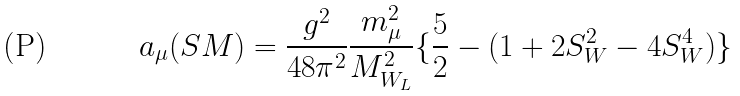Convert formula to latex. <formula><loc_0><loc_0><loc_500><loc_500>a _ { \mu } ( S M ) = \frac { g ^ { 2 } } { 4 8 \pi ^ { 2 } } \frac { m _ { \mu } ^ { 2 } } { M _ { W _ { L } } ^ { 2 } } \{ \frac { 5 } { 2 } - ( 1 + 2 S _ { W } ^ { 2 } - 4 S _ { W } ^ { 4 } ) \}</formula> 